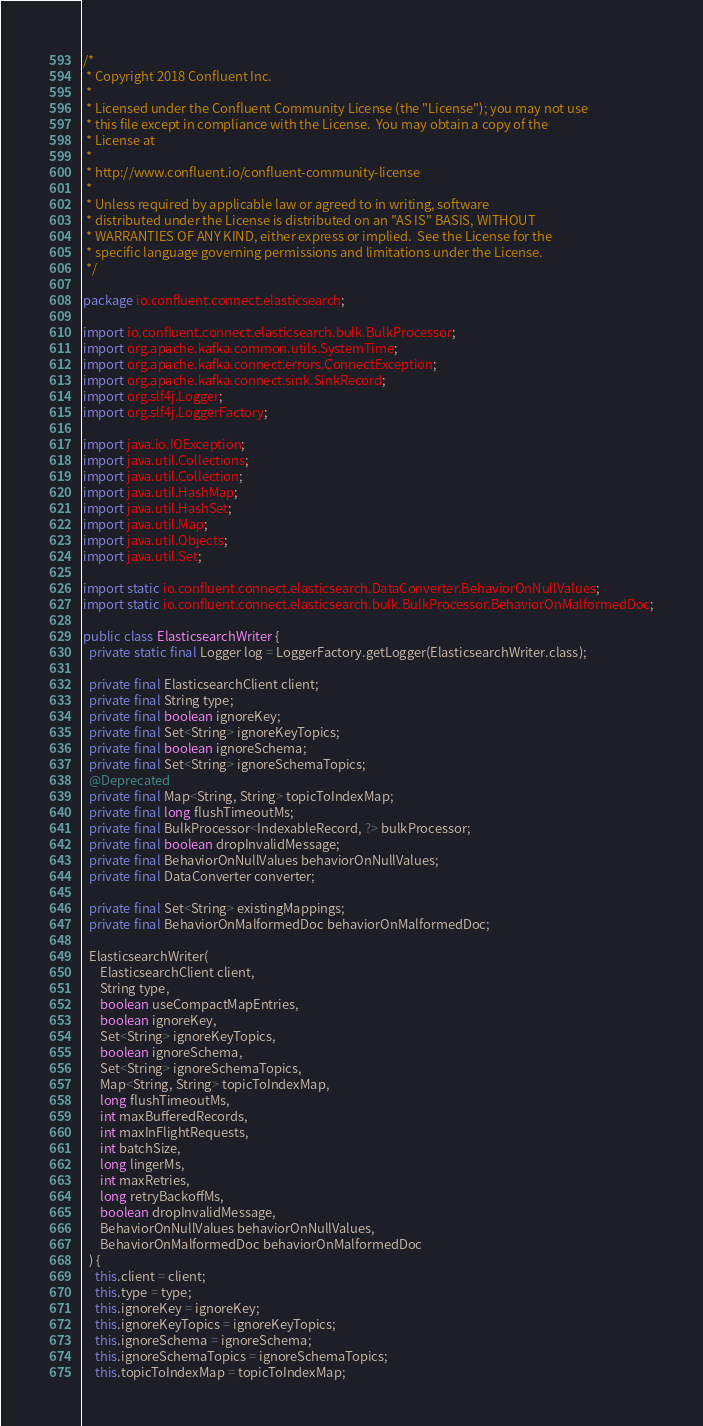Convert code to text. <code><loc_0><loc_0><loc_500><loc_500><_Java_>/*
 * Copyright 2018 Confluent Inc.
 *
 * Licensed under the Confluent Community License (the "License"); you may not use
 * this file except in compliance with the License.  You may obtain a copy of the
 * License at
 *
 * http://www.confluent.io/confluent-community-license
 *
 * Unless required by applicable law or agreed to in writing, software
 * distributed under the License is distributed on an "AS IS" BASIS, WITHOUT
 * WARRANTIES OF ANY KIND, either express or implied.  See the License for the
 * specific language governing permissions and limitations under the License.
 */

package io.confluent.connect.elasticsearch;

import io.confluent.connect.elasticsearch.bulk.BulkProcessor;
import org.apache.kafka.common.utils.SystemTime;
import org.apache.kafka.connect.errors.ConnectException;
import org.apache.kafka.connect.sink.SinkRecord;
import org.slf4j.Logger;
import org.slf4j.LoggerFactory;

import java.io.IOException;
import java.util.Collections;
import java.util.Collection;
import java.util.HashMap;
import java.util.HashSet;
import java.util.Map;
import java.util.Objects;
import java.util.Set;

import static io.confluent.connect.elasticsearch.DataConverter.BehaviorOnNullValues;
import static io.confluent.connect.elasticsearch.bulk.BulkProcessor.BehaviorOnMalformedDoc;

public class ElasticsearchWriter {
  private static final Logger log = LoggerFactory.getLogger(ElasticsearchWriter.class);

  private final ElasticsearchClient client;
  private final String type;
  private final boolean ignoreKey;
  private final Set<String> ignoreKeyTopics;
  private final boolean ignoreSchema;
  private final Set<String> ignoreSchemaTopics;
  @Deprecated
  private final Map<String, String> topicToIndexMap;
  private final long flushTimeoutMs;
  private final BulkProcessor<IndexableRecord, ?> bulkProcessor;
  private final boolean dropInvalidMessage;
  private final BehaviorOnNullValues behaviorOnNullValues;
  private final DataConverter converter;

  private final Set<String> existingMappings;
  private final BehaviorOnMalformedDoc behaviorOnMalformedDoc;

  ElasticsearchWriter(
      ElasticsearchClient client,
      String type,
      boolean useCompactMapEntries,
      boolean ignoreKey,
      Set<String> ignoreKeyTopics,
      boolean ignoreSchema,
      Set<String> ignoreSchemaTopics,
      Map<String, String> topicToIndexMap,
      long flushTimeoutMs,
      int maxBufferedRecords,
      int maxInFlightRequests,
      int batchSize,
      long lingerMs,
      int maxRetries,
      long retryBackoffMs,
      boolean dropInvalidMessage,
      BehaviorOnNullValues behaviorOnNullValues,
      BehaviorOnMalformedDoc behaviorOnMalformedDoc
  ) {
    this.client = client;
    this.type = type;
    this.ignoreKey = ignoreKey;
    this.ignoreKeyTopics = ignoreKeyTopics;
    this.ignoreSchema = ignoreSchema;
    this.ignoreSchemaTopics = ignoreSchemaTopics;
    this.topicToIndexMap = topicToIndexMap;</code> 